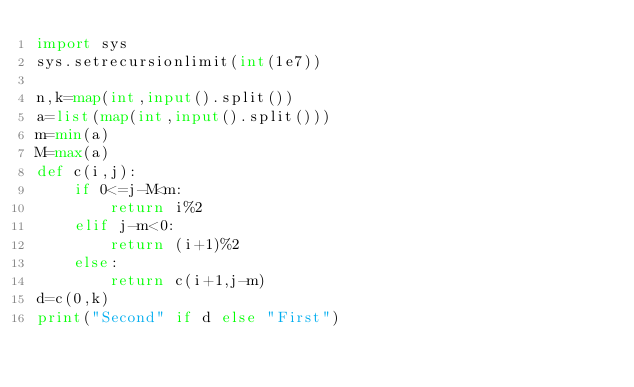<code> <loc_0><loc_0><loc_500><loc_500><_Python_>import sys
sys.setrecursionlimit(int(1e7))

n,k=map(int,input().split())
a=list(map(int,input().split()))
m=min(a)
M=max(a)
def c(i,j):
    if 0<=j-M<m:
        return i%2
    elif j-m<0:
        return (i+1)%2
    else:
        return c(i+1,j-m)
d=c(0,k)
print("Second" if d else "First")</code> 